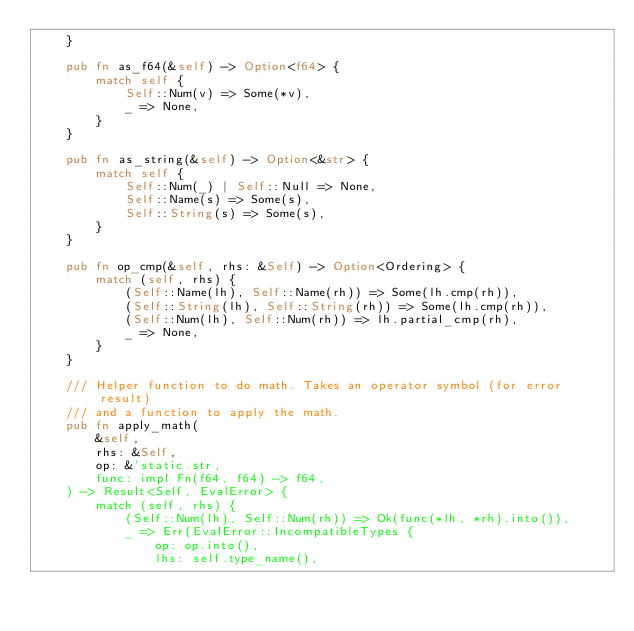<code> <loc_0><loc_0><loc_500><loc_500><_Rust_>    }

    pub fn as_f64(&self) -> Option<f64> {
        match self {
            Self::Num(v) => Some(*v),
            _ => None,
        }
    }

    pub fn as_string(&self) -> Option<&str> {
        match self {
            Self::Num(_) | Self::Null => None,
            Self::Name(s) => Some(s),
            Self::String(s) => Some(s),
        }
    }

    pub fn op_cmp(&self, rhs: &Self) -> Option<Ordering> {
        match (self, rhs) {
            (Self::Name(lh), Self::Name(rh)) => Some(lh.cmp(rh)),
            (Self::String(lh), Self::String(rh)) => Some(lh.cmp(rh)),
            (Self::Num(lh), Self::Num(rh)) => lh.partial_cmp(rh),
            _ => None,
        }
    }

    /// Helper function to do math. Takes an operator symbol (for error result)
    /// and a function to apply the math.
    pub fn apply_math(
        &self,
        rhs: &Self,
        op: &'static str,
        func: impl Fn(f64, f64) -> f64,
    ) -> Result<Self, EvalError> {
        match (self, rhs) {
            (Self::Num(lh), Self::Num(rh)) => Ok(func(*lh, *rh).into()),
            _ => Err(EvalError::IncompatibleTypes {
                op: op.into(),
                lhs: self.type_name(),</code> 